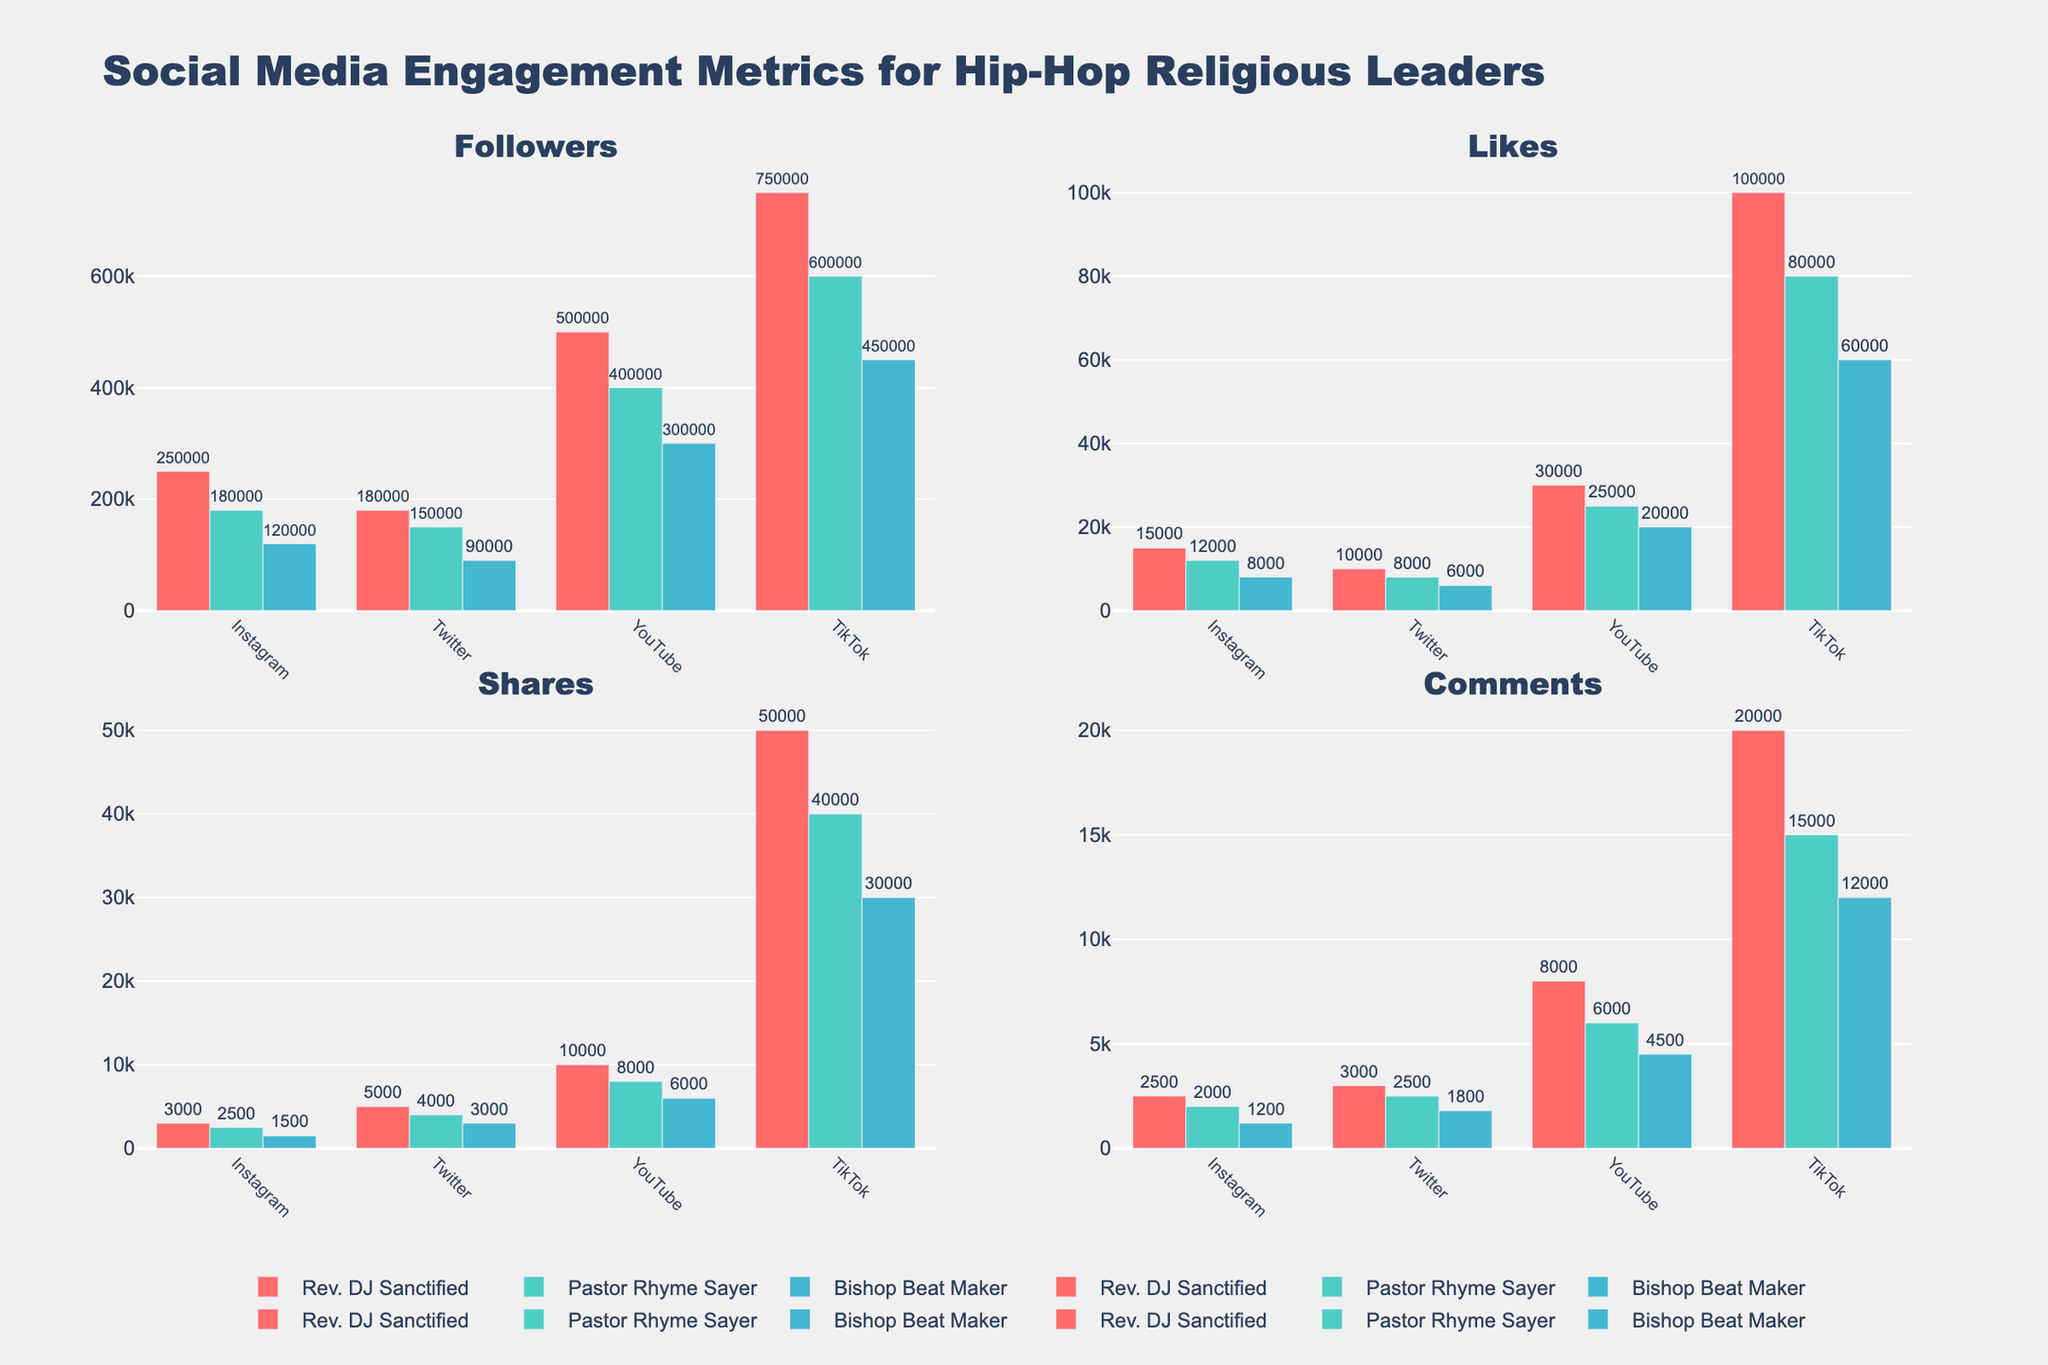What is the primary color used for Rev. DJ Sanctified in all subplots? The bars representing Rev. DJ Sanctified are consistently colored red across all subplots.
Answer: Red How many total platforms are covered in the figure? The figure covers four platforms: Instagram, Twitter, YouTube, and TikTok. Each platform is represented with data from the subplots.
Answer: Four Which leader has the most followers on TikTok? By examining the subplot for followers, it is clear that Rev. DJ Sanctified has the highest number of followers on TikTok.
Answer: Rev. DJ Sanctified Between Instagram and Twitter, which platform has higher total engagement for Pastor Rhyme Sayer in terms of likes? To find this, sum the likes from Instagram (12,000) and Twitter (8,000) for Pastor Rhyme Sayer. Instagram: 12,000, Twitter: 8,000
Answer: Instagram How does Bishop Beat Maker's number of shares on YouTube compare with his number of shares on Instagram? On YouTube, Bishop Beat Maker has 6,000 shares, while on Instagram, he has 1,500 shares. YouTube is significantly higher.
Answer: YouTube is higher What is the combined number of comments that Rev. DJ Sanctified has on all platforms? Summing up comments for Rev. DJ Sanctified across all platforms: Instagram (2,500), Twitter (3,000), YouTube (8,000), TikTok (20,000). Total = 2,500 + 3,000 + 8,000 + 20,000
Answer: 33,500 Which platform shows the highest number of likes for any leader and who is the leader? The highest number of likes observed is on TikTok for Rev. DJ Sanctified, with 100,000 likes.
Answer: TikTok, Rev. DJ Sanctified Which leader has the lowest number of likes on YouTube? By examining the subplot for likes, Bishop Beat Maker has the lowest number of likes on YouTube with 20,000.
Answer: Bishop Beat Maker Is Pastor Rhyme Sayer's total number of shares on TikTok greater than his total number of shares on Instagram and Twitter combined? TikTok shares for Pastor Rhyme Sayer are 40,000. The combined shares on Instagram (2,500) and Twitter (4,000) sum to 6,500. 40,000 > 6,500.
Answer: Yes 